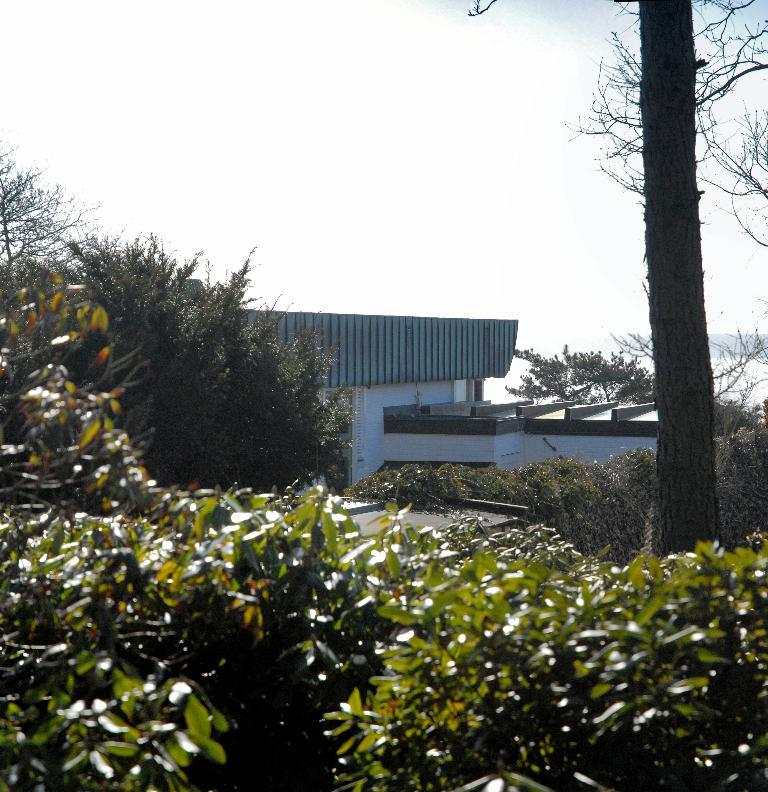What type of vegetation can be seen in the image? There are trees in the image. What structure is present in the image? There is a building in the image. What is visible at the top of the image? The sky is visible at the top of the image. What type of chain can be seen hanging from the trees in the image? There is no chain present in the image; it only features trees and a building. What show is being performed in front of the building in the image? There is no show or performance taking place in the image; it only shows trees, a building, and the sky. 